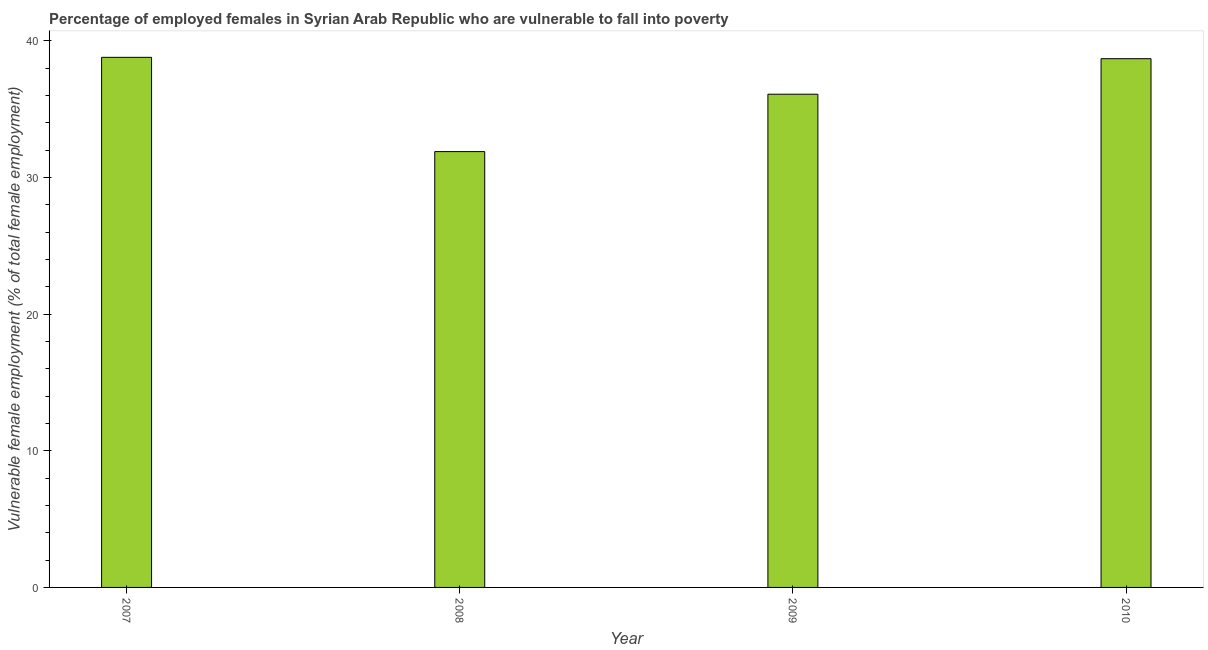Does the graph contain any zero values?
Make the answer very short. No. What is the title of the graph?
Ensure brevity in your answer.  Percentage of employed females in Syrian Arab Republic who are vulnerable to fall into poverty. What is the label or title of the Y-axis?
Give a very brief answer. Vulnerable female employment (% of total female employment). What is the percentage of employed females who are vulnerable to fall into poverty in 2007?
Provide a succinct answer. 38.8. Across all years, what is the maximum percentage of employed females who are vulnerable to fall into poverty?
Give a very brief answer. 38.8. Across all years, what is the minimum percentage of employed females who are vulnerable to fall into poverty?
Your answer should be compact. 31.9. In which year was the percentage of employed females who are vulnerable to fall into poverty maximum?
Ensure brevity in your answer.  2007. What is the sum of the percentage of employed females who are vulnerable to fall into poverty?
Your answer should be very brief. 145.5. What is the difference between the percentage of employed females who are vulnerable to fall into poverty in 2008 and 2009?
Give a very brief answer. -4.2. What is the average percentage of employed females who are vulnerable to fall into poverty per year?
Give a very brief answer. 36.38. What is the median percentage of employed females who are vulnerable to fall into poverty?
Offer a very short reply. 37.4. In how many years, is the percentage of employed females who are vulnerable to fall into poverty greater than 14 %?
Your answer should be compact. 4. Do a majority of the years between 2008 and 2009 (inclusive) have percentage of employed females who are vulnerable to fall into poverty greater than 32 %?
Offer a very short reply. No. What is the ratio of the percentage of employed females who are vulnerable to fall into poverty in 2008 to that in 2010?
Offer a terse response. 0.82. Is the sum of the percentage of employed females who are vulnerable to fall into poverty in 2008 and 2010 greater than the maximum percentage of employed females who are vulnerable to fall into poverty across all years?
Give a very brief answer. Yes. What is the difference between the highest and the lowest percentage of employed females who are vulnerable to fall into poverty?
Offer a terse response. 6.9. In how many years, is the percentage of employed females who are vulnerable to fall into poverty greater than the average percentage of employed females who are vulnerable to fall into poverty taken over all years?
Offer a very short reply. 2. How many bars are there?
Keep it short and to the point. 4. Are all the bars in the graph horizontal?
Offer a terse response. No. How many years are there in the graph?
Provide a succinct answer. 4. Are the values on the major ticks of Y-axis written in scientific E-notation?
Keep it short and to the point. No. What is the Vulnerable female employment (% of total female employment) of 2007?
Give a very brief answer. 38.8. What is the Vulnerable female employment (% of total female employment) of 2008?
Provide a short and direct response. 31.9. What is the Vulnerable female employment (% of total female employment) of 2009?
Your answer should be very brief. 36.1. What is the Vulnerable female employment (% of total female employment) in 2010?
Offer a very short reply. 38.7. What is the difference between the Vulnerable female employment (% of total female employment) in 2007 and 2008?
Provide a short and direct response. 6.9. What is the difference between the Vulnerable female employment (% of total female employment) in 2008 and 2010?
Offer a very short reply. -6.8. What is the ratio of the Vulnerable female employment (% of total female employment) in 2007 to that in 2008?
Make the answer very short. 1.22. What is the ratio of the Vulnerable female employment (% of total female employment) in 2007 to that in 2009?
Your answer should be compact. 1.07. What is the ratio of the Vulnerable female employment (% of total female employment) in 2007 to that in 2010?
Your response must be concise. 1. What is the ratio of the Vulnerable female employment (% of total female employment) in 2008 to that in 2009?
Your answer should be very brief. 0.88. What is the ratio of the Vulnerable female employment (% of total female employment) in 2008 to that in 2010?
Keep it short and to the point. 0.82. What is the ratio of the Vulnerable female employment (% of total female employment) in 2009 to that in 2010?
Offer a terse response. 0.93. 